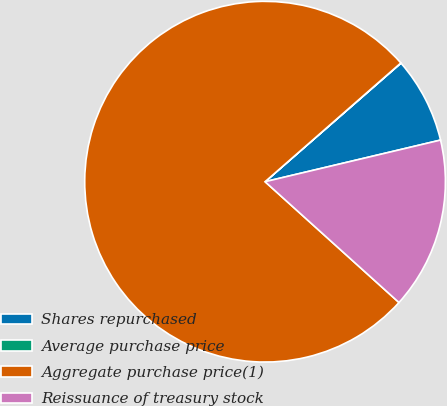Convert chart. <chart><loc_0><loc_0><loc_500><loc_500><pie_chart><fcel>Shares repurchased<fcel>Average purchase price<fcel>Aggregate purchase price(1)<fcel>Reissuance of treasury stock<nl><fcel>7.71%<fcel>0.02%<fcel>76.88%<fcel>15.39%<nl></chart> 